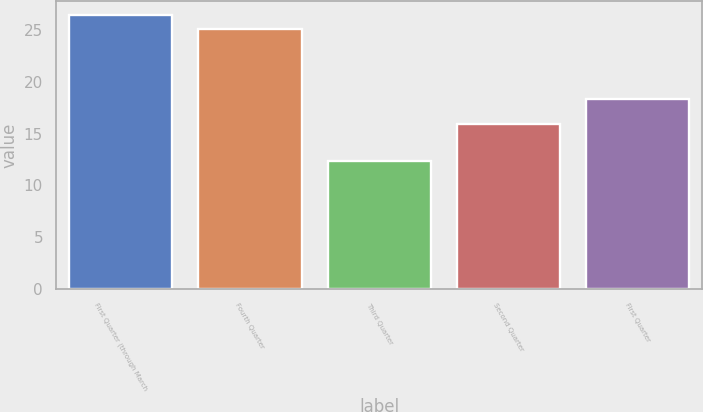<chart> <loc_0><loc_0><loc_500><loc_500><bar_chart><fcel>First Quarter (through March<fcel>Fourth Quarter<fcel>Third Quarter<fcel>Second Quarter<fcel>First Quarter<nl><fcel>26.43<fcel>25.05<fcel>12.36<fcel>15.88<fcel>18.34<nl></chart> 